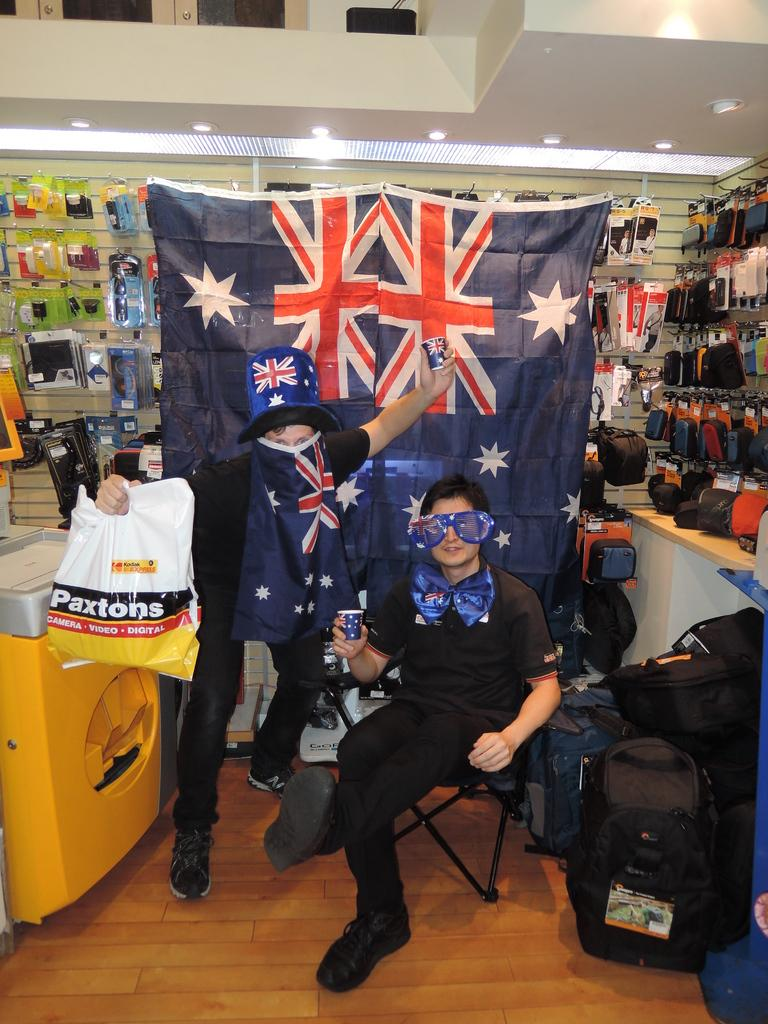Provide a one-sentence caption for the provided image. Men are posing in front of flags holding a Paxtons bag. 